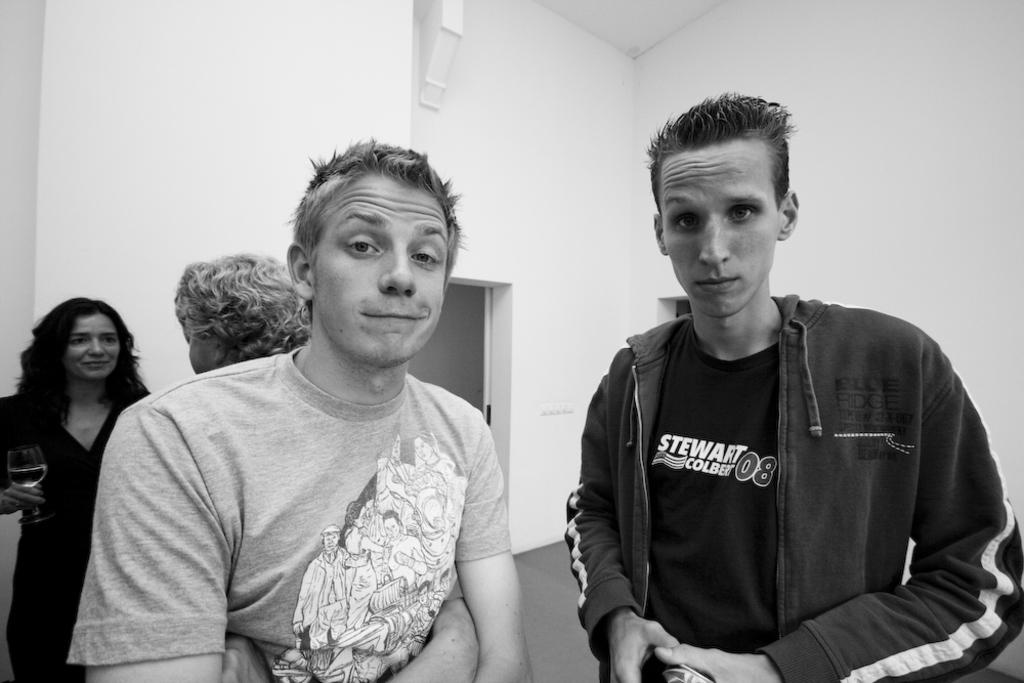How many people are present in the image? There are four people standing in the center of the image. What is the lady on the left holding? The lady on the left is holding a wine glass. What can be seen in the background of the image? There is a door and a wall in the background of the image. What is the distance between the people and the wall in the image? The provided facts do not give information about the distance between the people and the wall, so it cannot be determined from the image. 